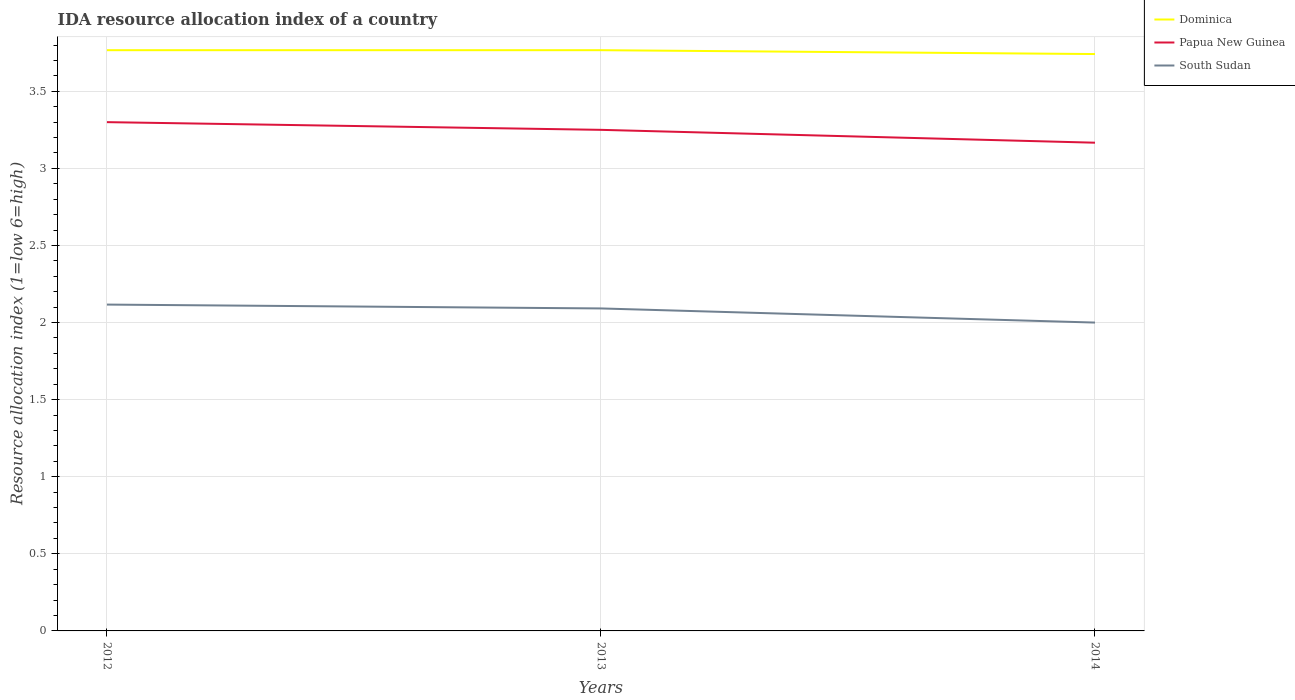How many different coloured lines are there?
Offer a terse response. 3. Does the line corresponding to Papua New Guinea intersect with the line corresponding to Dominica?
Keep it short and to the point. No. Is the number of lines equal to the number of legend labels?
Your answer should be very brief. Yes. Across all years, what is the maximum IDA resource allocation index in South Sudan?
Offer a very short reply. 2. In which year was the IDA resource allocation index in Dominica maximum?
Provide a short and direct response. 2014. What is the total IDA resource allocation index in South Sudan in the graph?
Keep it short and to the point. 0.12. What is the difference between the highest and the second highest IDA resource allocation index in Dominica?
Your response must be concise. 0.02. Is the IDA resource allocation index in South Sudan strictly greater than the IDA resource allocation index in Papua New Guinea over the years?
Your answer should be very brief. Yes. How many years are there in the graph?
Offer a very short reply. 3. What is the difference between two consecutive major ticks on the Y-axis?
Make the answer very short. 0.5. Are the values on the major ticks of Y-axis written in scientific E-notation?
Your answer should be very brief. No. Does the graph contain any zero values?
Keep it short and to the point. No. Where does the legend appear in the graph?
Provide a short and direct response. Top right. How many legend labels are there?
Offer a very short reply. 3. What is the title of the graph?
Keep it short and to the point. IDA resource allocation index of a country. What is the label or title of the Y-axis?
Provide a short and direct response. Resource allocation index (1=low 6=high). What is the Resource allocation index (1=low 6=high) in Dominica in 2012?
Provide a short and direct response. 3.77. What is the Resource allocation index (1=low 6=high) in South Sudan in 2012?
Ensure brevity in your answer.  2.12. What is the Resource allocation index (1=low 6=high) of Dominica in 2013?
Your answer should be compact. 3.77. What is the Resource allocation index (1=low 6=high) of Papua New Guinea in 2013?
Provide a short and direct response. 3.25. What is the Resource allocation index (1=low 6=high) in South Sudan in 2013?
Your answer should be very brief. 2.09. What is the Resource allocation index (1=low 6=high) of Dominica in 2014?
Provide a short and direct response. 3.74. What is the Resource allocation index (1=low 6=high) of Papua New Guinea in 2014?
Offer a terse response. 3.17. Across all years, what is the maximum Resource allocation index (1=low 6=high) in Dominica?
Your answer should be very brief. 3.77. Across all years, what is the maximum Resource allocation index (1=low 6=high) in South Sudan?
Make the answer very short. 2.12. Across all years, what is the minimum Resource allocation index (1=low 6=high) in Dominica?
Provide a succinct answer. 3.74. Across all years, what is the minimum Resource allocation index (1=low 6=high) of Papua New Guinea?
Give a very brief answer. 3.17. What is the total Resource allocation index (1=low 6=high) in Dominica in the graph?
Provide a succinct answer. 11.28. What is the total Resource allocation index (1=low 6=high) of Papua New Guinea in the graph?
Provide a short and direct response. 9.72. What is the total Resource allocation index (1=low 6=high) in South Sudan in the graph?
Offer a terse response. 6.21. What is the difference between the Resource allocation index (1=low 6=high) in Dominica in 2012 and that in 2013?
Your answer should be compact. 0. What is the difference between the Resource allocation index (1=low 6=high) of South Sudan in 2012 and that in 2013?
Give a very brief answer. 0.03. What is the difference between the Resource allocation index (1=low 6=high) of Dominica in 2012 and that in 2014?
Ensure brevity in your answer.  0.03. What is the difference between the Resource allocation index (1=low 6=high) of Papua New Guinea in 2012 and that in 2014?
Keep it short and to the point. 0.13. What is the difference between the Resource allocation index (1=low 6=high) of South Sudan in 2012 and that in 2014?
Offer a terse response. 0.12. What is the difference between the Resource allocation index (1=low 6=high) in Dominica in 2013 and that in 2014?
Provide a succinct answer. 0.03. What is the difference between the Resource allocation index (1=low 6=high) in Papua New Guinea in 2013 and that in 2014?
Your response must be concise. 0.08. What is the difference between the Resource allocation index (1=low 6=high) of South Sudan in 2013 and that in 2014?
Make the answer very short. 0.09. What is the difference between the Resource allocation index (1=low 6=high) in Dominica in 2012 and the Resource allocation index (1=low 6=high) in Papua New Guinea in 2013?
Your answer should be compact. 0.52. What is the difference between the Resource allocation index (1=low 6=high) of Dominica in 2012 and the Resource allocation index (1=low 6=high) of South Sudan in 2013?
Make the answer very short. 1.68. What is the difference between the Resource allocation index (1=low 6=high) of Papua New Guinea in 2012 and the Resource allocation index (1=low 6=high) of South Sudan in 2013?
Make the answer very short. 1.21. What is the difference between the Resource allocation index (1=low 6=high) of Dominica in 2012 and the Resource allocation index (1=low 6=high) of Papua New Guinea in 2014?
Keep it short and to the point. 0.6. What is the difference between the Resource allocation index (1=low 6=high) in Dominica in 2012 and the Resource allocation index (1=low 6=high) in South Sudan in 2014?
Your answer should be very brief. 1.77. What is the difference between the Resource allocation index (1=low 6=high) of Papua New Guinea in 2012 and the Resource allocation index (1=low 6=high) of South Sudan in 2014?
Your response must be concise. 1.3. What is the difference between the Resource allocation index (1=low 6=high) in Dominica in 2013 and the Resource allocation index (1=low 6=high) in Papua New Guinea in 2014?
Ensure brevity in your answer.  0.6. What is the difference between the Resource allocation index (1=low 6=high) in Dominica in 2013 and the Resource allocation index (1=low 6=high) in South Sudan in 2014?
Ensure brevity in your answer.  1.77. What is the average Resource allocation index (1=low 6=high) in Dominica per year?
Provide a succinct answer. 3.76. What is the average Resource allocation index (1=low 6=high) of Papua New Guinea per year?
Offer a terse response. 3.24. What is the average Resource allocation index (1=low 6=high) of South Sudan per year?
Provide a succinct answer. 2.07. In the year 2012, what is the difference between the Resource allocation index (1=low 6=high) in Dominica and Resource allocation index (1=low 6=high) in Papua New Guinea?
Your response must be concise. 0.47. In the year 2012, what is the difference between the Resource allocation index (1=low 6=high) in Dominica and Resource allocation index (1=low 6=high) in South Sudan?
Make the answer very short. 1.65. In the year 2012, what is the difference between the Resource allocation index (1=low 6=high) of Papua New Guinea and Resource allocation index (1=low 6=high) of South Sudan?
Provide a short and direct response. 1.18. In the year 2013, what is the difference between the Resource allocation index (1=low 6=high) of Dominica and Resource allocation index (1=low 6=high) of Papua New Guinea?
Ensure brevity in your answer.  0.52. In the year 2013, what is the difference between the Resource allocation index (1=low 6=high) in Dominica and Resource allocation index (1=low 6=high) in South Sudan?
Offer a terse response. 1.68. In the year 2013, what is the difference between the Resource allocation index (1=low 6=high) in Papua New Guinea and Resource allocation index (1=low 6=high) in South Sudan?
Your answer should be very brief. 1.16. In the year 2014, what is the difference between the Resource allocation index (1=low 6=high) of Dominica and Resource allocation index (1=low 6=high) of Papua New Guinea?
Provide a short and direct response. 0.57. In the year 2014, what is the difference between the Resource allocation index (1=low 6=high) in Dominica and Resource allocation index (1=low 6=high) in South Sudan?
Keep it short and to the point. 1.74. In the year 2014, what is the difference between the Resource allocation index (1=low 6=high) in Papua New Guinea and Resource allocation index (1=low 6=high) in South Sudan?
Provide a succinct answer. 1.17. What is the ratio of the Resource allocation index (1=low 6=high) of Papua New Guinea in 2012 to that in 2013?
Your answer should be very brief. 1.02. What is the ratio of the Resource allocation index (1=low 6=high) of South Sudan in 2012 to that in 2013?
Provide a short and direct response. 1.01. What is the ratio of the Resource allocation index (1=low 6=high) of Dominica in 2012 to that in 2014?
Provide a succinct answer. 1.01. What is the ratio of the Resource allocation index (1=low 6=high) of Papua New Guinea in 2012 to that in 2014?
Make the answer very short. 1.04. What is the ratio of the Resource allocation index (1=low 6=high) in South Sudan in 2012 to that in 2014?
Your response must be concise. 1.06. What is the ratio of the Resource allocation index (1=low 6=high) of Papua New Guinea in 2013 to that in 2014?
Provide a short and direct response. 1.03. What is the ratio of the Resource allocation index (1=low 6=high) in South Sudan in 2013 to that in 2014?
Provide a short and direct response. 1.05. What is the difference between the highest and the second highest Resource allocation index (1=low 6=high) of South Sudan?
Offer a very short reply. 0.03. What is the difference between the highest and the lowest Resource allocation index (1=low 6=high) of Dominica?
Ensure brevity in your answer.  0.03. What is the difference between the highest and the lowest Resource allocation index (1=low 6=high) in Papua New Guinea?
Ensure brevity in your answer.  0.13. What is the difference between the highest and the lowest Resource allocation index (1=low 6=high) in South Sudan?
Make the answer very short. 0.12. 